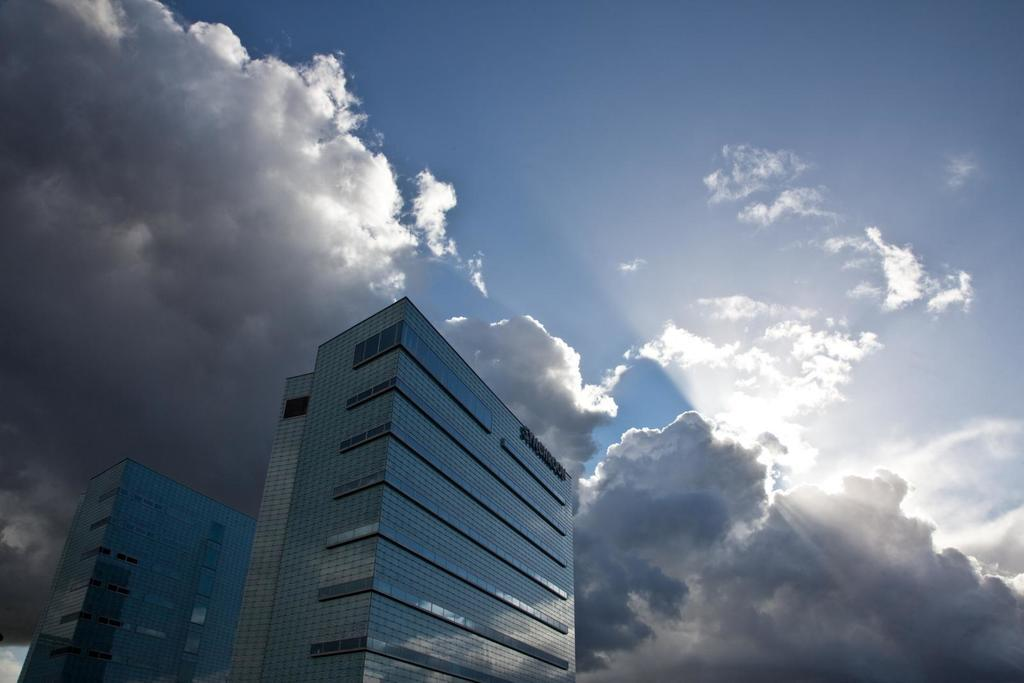What type of structures can be seen in the image? There are buildings in the image. What is the condition of the sky in the image? The sky is cloudy in the image. What type of drum is being played in the image? There is no drum present in the image; it only features buildings and a cloudy sky. 